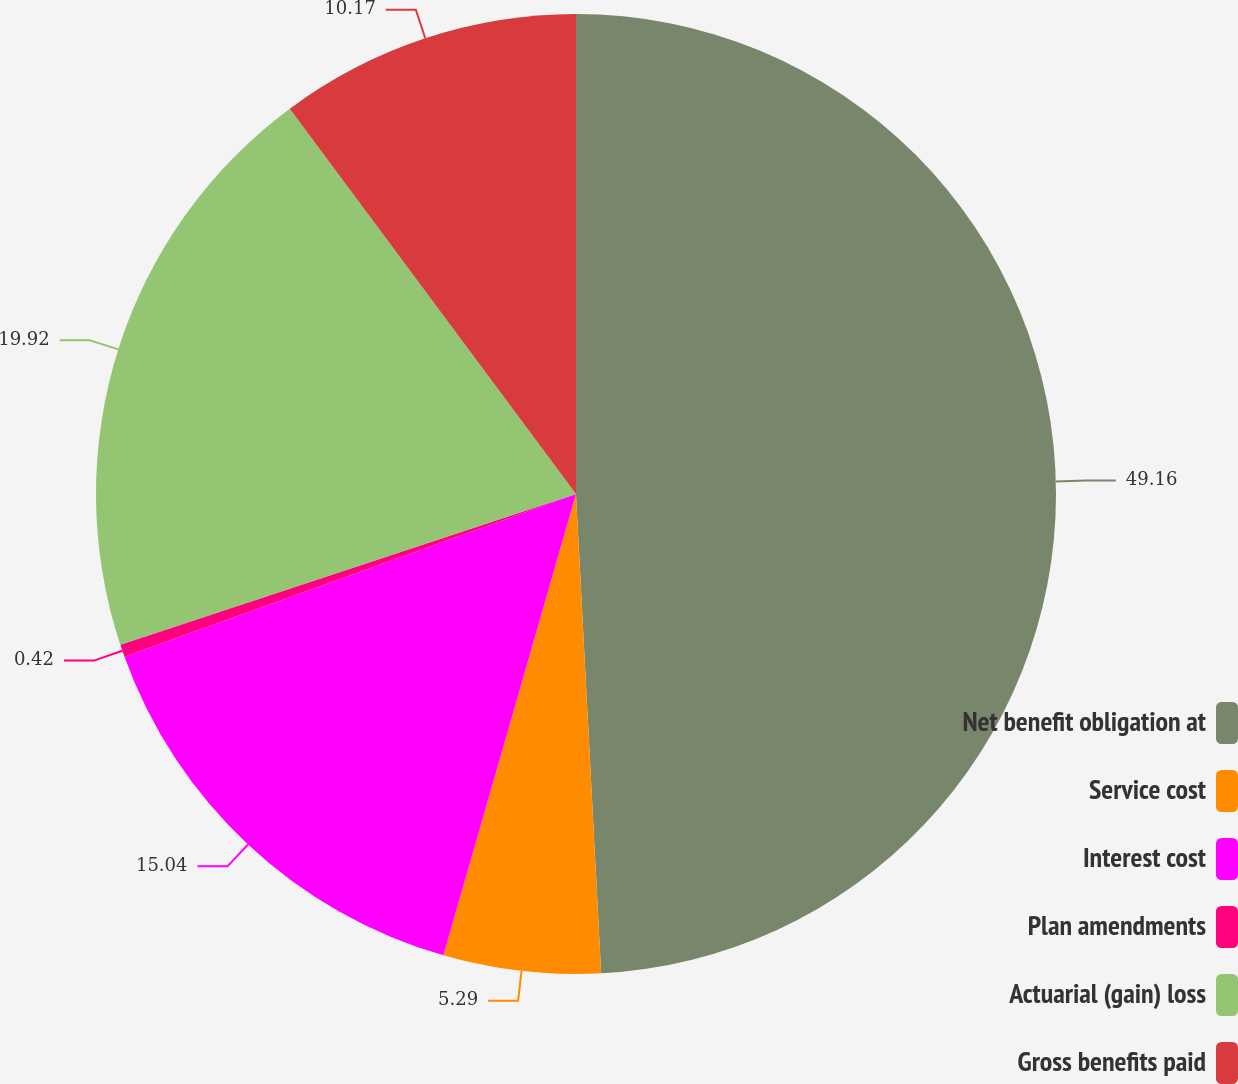Convert chart. <chart><loc_0><loc_0><loc_500><loc_500><pie_chart><fcel>Net benefit obligation at<fcel>Service cost<fcel>Interest cost<fcel>Plan amendments<fcel>Actuarial (gain) loss<fcel>Gross benefits paid<nl><fcel>49.17%<fcel>5.29%<fcel>15.04%<fcel>0.42%<fcel>19.92%<fcel>10.17%<nl></chart> 